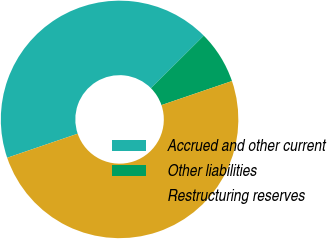Convert chart. <chart><loc_0><loc_0><loc_500><loc_500><pie_chart><fcel>Accrued and other current<fcel>Other liabilities<fcel>Restructuring reserves<nl><fcel>42.78%<fcel>7.22%<fcel>50.0%<nl></chart> 